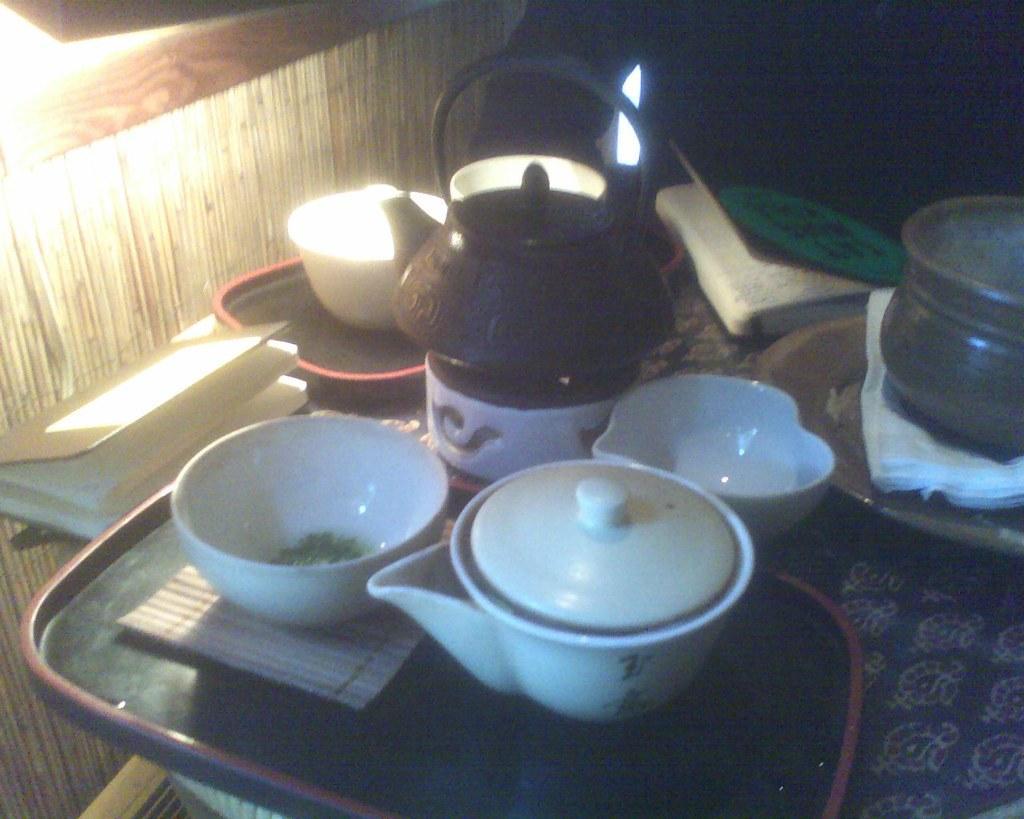Could you give a brief overview of what you see in this image? In this image we can see the table and on the table we can see the trays, bowls, tissues, books and also some other objects. We can also see the lights and also the wall. 